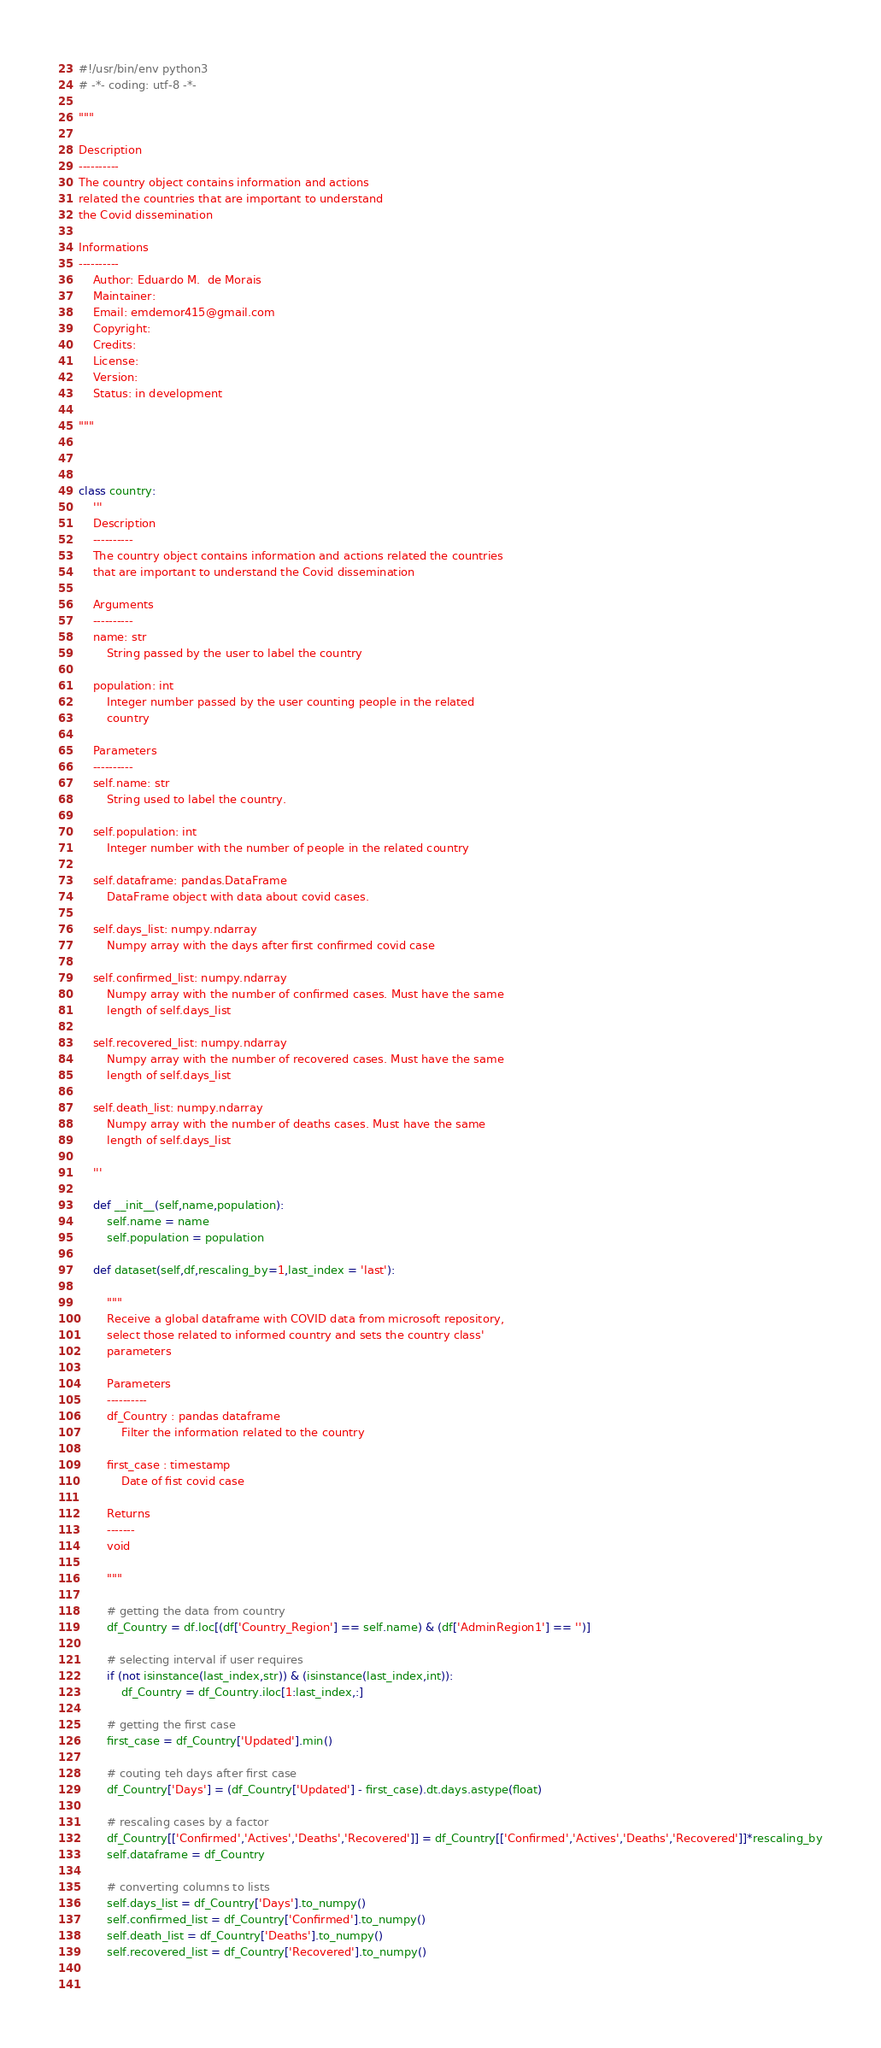<code> <loc_0><loc_0><loc_500><loc_500><_Python_>#!/usr/bin/env python3
# -*- coding: utf-8 -*-

"""

Description
----------
The country object contains information and actions 
related the countries that are important to understand 
the Covid dissemination

Informations
----------
    Author: Eduardo M.  de Morais
    Maintainer:
    Email: emdemor415@gmail.com
    Copyright:
    Credits:
    License:
    Version:
    Status: in development
    
"""



class country:
    '''
    Description
    ----------
    The country object contains information and actions related the countries
    that are important to understand the Covid dissemination

    Arguments
    ----------
    name: str
        String passed by the user to label the country
        
    population: int
        Integer number passed by the user counting people in the related 
        country

    Parameters
    ----------
    self.name: str
        String used to label the country.
        
    self.population: int
        Integer number with the number of people in the related country
        
    self.dataframe: pandas.DataFrame
        DataFrame object with data about covid cases.
        
    self.days_list: numpy.ndarray
        Numpy array with the days after first confirmed covid case
        
    self.confirmed_list: numpy.ndarray
        Numpy array with the number of confirmed cases. Must have the same 
        length of self.days_list
        
    self.recovered_list: numpy.ndarray
        Numpy array with the number of recovered cases. Must have the same 
        length of self.days_list
        
    self.death_list: numpy.ndarray
        Numpy array with the number of deaths cases. Must have the same 
        length of self.days_list
        
    '''
    
    def __init__(self,name,population):
        self.name = name
        self.population = population
        
    def dataset(self,df,rescaling_by=1,last_index = 'last'):
        
        """
        Receive a global dataframe with COVID data from microsoft repository,
        select those related to informed country and sets the country class' 
        parameters

        Parameters
        ----------
        df_Country : pandas dataframe
            Filter the information related to the country
            
        first_case : timestamp
            Date of fist covid case
        
        Returns
        -------
        void
        
        """
        
        # getting the data from country
        df_Country = df.loc[(df['Country_Region'] == self.name) & (df['AdminRegion1'] == '')]

        # selecting interval if user requires
        if (not isinstance(last_index,str)) & (isinstance(last_index,int)):
            df_Country = df_Country.iloc[1:last_index,:]
        
        # getting the first case
        first_case = df_Country['Updated'].min()
        
        # couting teh days after first case
        df_Country['Days'] = (df_Country['Updated'] - first_case).dt.days.astype(float)
        
        # rescaling cases by a factor
        df_Country[['Confirmed','Actives','Deaths','Recovered']] = df_Country[['Confirmed','Actives','Deaths','Recovered']]*rescaling_by
        self.dataframe = df_Country
        
        # converting columns to lists
        self.days_list = df_Country['Days'].to_numpy()
        self.confirmed_list = df_Country['Confirmed'].to_numpy()
        self.death_list = df_Country['Deaths'].to_numpy()
        self.recovered_list = df_Country['Recovered'].to_numpy()
        
        </code> 